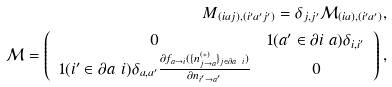Convert formula to latex. <formula><loc_0><loc_0><loc_500><loc_500>M _ { ( i a j ) , ( i ^ { \prime } a ^ { \prime } j ^ { \prime } ) } = \delta _ { j , j ^ { \prime } } \mathcal { M } _ { ( i a ) , ( i ^ { \prime } a ^ { \prime } ) } , \\ \mathcal { M } = \left ( \begin{array} { c c } 0 & 1 ( a ^ { \prime } \in \partial i \ a ) \delta _ { i , i ^ { \prime } } \\ 1 ( i ^ { \prime } \in \partial a \ i ) \delta _ { a , a ^ { \prime } } \frac { \partial f _ { a \rightarrow i } ( \{ n _ { j \rightarrow a } ^ { ( * ) } \} _ { j \in \partial a \ i } ) } { \partial n _ { i ^ { \prime } \rightarrow a ^ { \prime } } } & 0 \\ \end{array} \right ) ,</formula> 